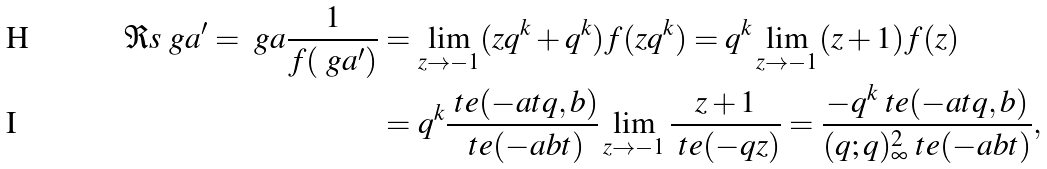Convert formula to latex. <formula><loc_0><loc_0><loc_500><loc_500>\Re s { \ g a ^ { \prime } = \ g a } \frac { 1 } { f ( \ g a ^ { \prime } ) } & = \lim _ { z \to - 1 } ( z q ^ { k } + q ^ { k } ) f ( z q ^ { k } ) = q ^ { k } \lim _ { z \to - 1 } ( z + 1 ) f ( z ) \\ & = q ^ { k } \frac { \ t e ( - a t q , b ) } { \ t e ( - a b t ) } \lim _ { z \to - 1 } \frac { z + 1 } { \ t e ( - q z ) } = \frac { - q ^ { k } \ t e ( - a t q , b ) } { ( q ; q ) _ { \infty } ^ { 2 } \ t e ( - a b t ) } ,</formula> 